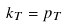<formula> <loc_0><loc_0><loc_500><loc_500>k _ { T } = p _ { T }</formula> 